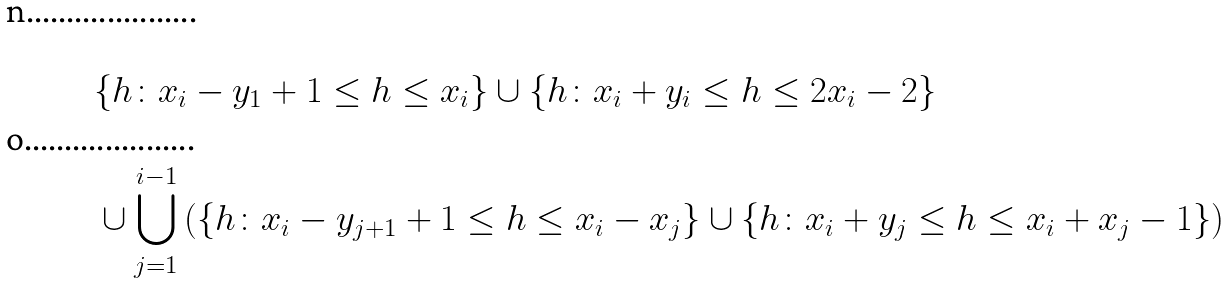<formula> <loc_0><loc_0><loc_500><loc_500>& \{ h \colon x _ { i } - y _ { 1 } + 1 \leq h \leq x _ { i } \} \cup \{ h \colon x _ { i } + y _ { i } \leq h \leq 2 x _ { i } - 2 \} \\ & \cup \bigcup _ { j = 1 } ^ { i - 1 } \left ( \{ h \colon x _ { i } - y _ { j + 1 } + 1 \leq h \leq x _ { i } - x _ { j } \} \cup \{ h \colon x _ { i } + y _ { j } \leq h \leq x _ { i } + x _ { j } - 1 \} \right )</formula> 